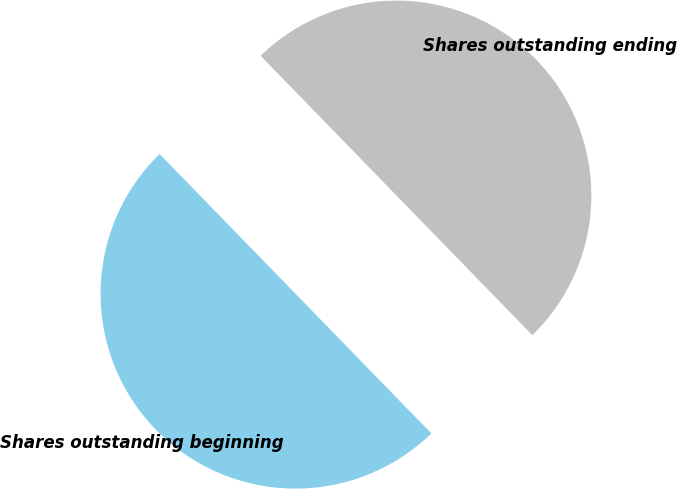Convert chart to OTSL. <chart><loc_0><loc_0><loc_500><loc_500><pie_chart><fcel>Shares outstanding beginning<fcel>Shares outstanding ending<nl><fcel>50.0%<fcel>50.0%<nl></chart> 